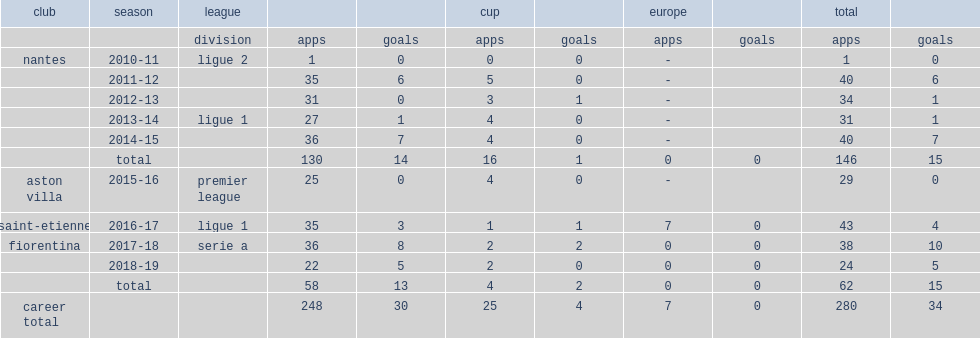How many appearances did veretout make for nantes over a period of five years? 146.0. 